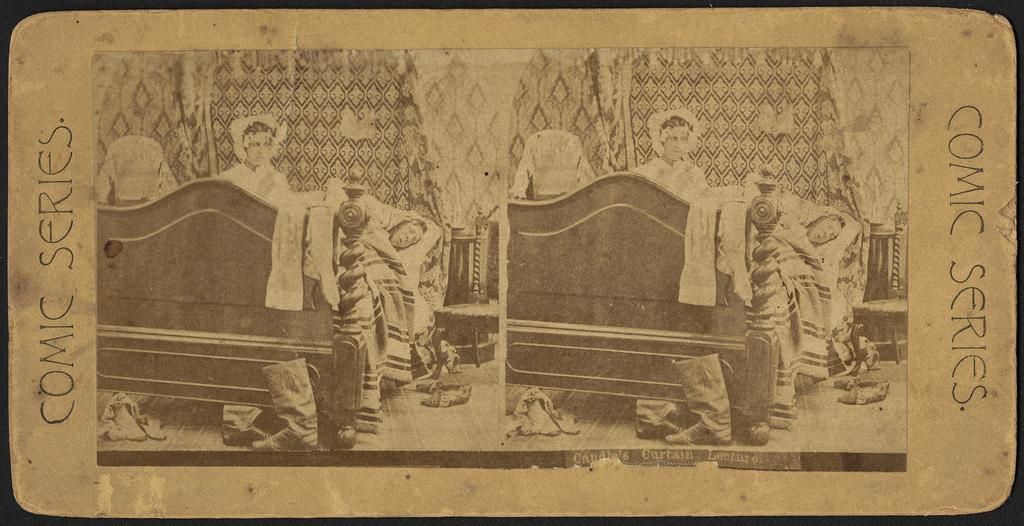What is the main subject of the image? The main subject of the image is a portrait. What can be found within the portrait? The portrait contains pictures. What type of bird can be seen flying in the portrait? There is no bird visible in the portrait; it contains pictures of other subjects. 